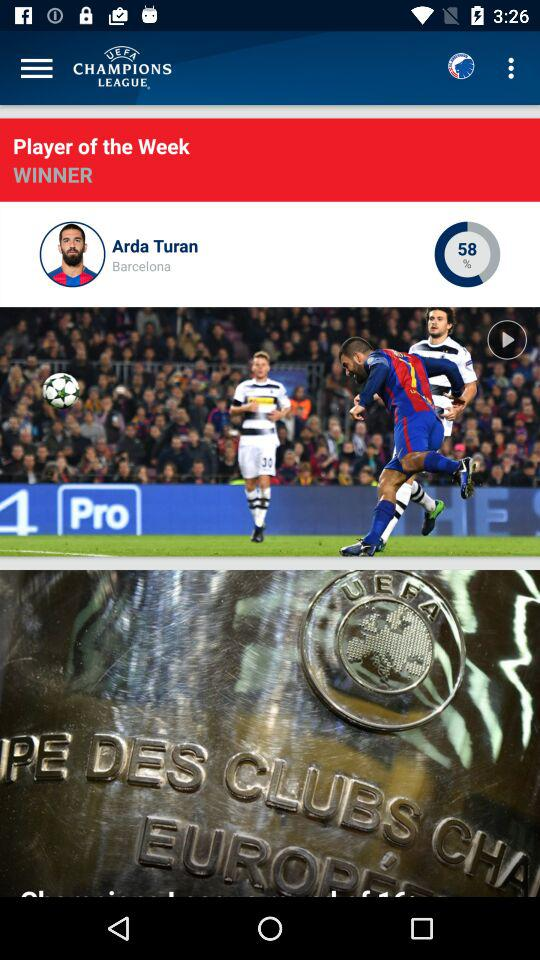What is the league name? The league name is "UEFA Champions". 